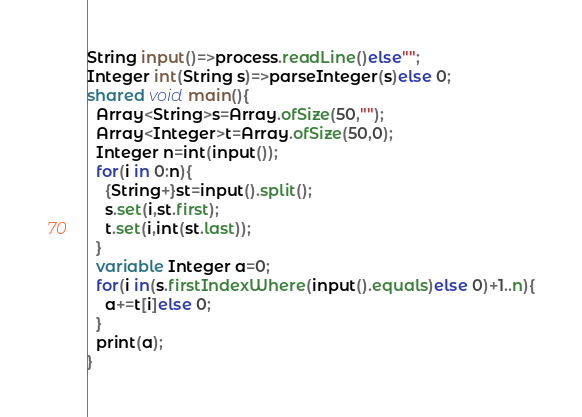<code> <loc_0><loc_0><loc_500><loc_500><_Ceylon_>String input()=>process.readLine()else""; 
Integer int(String s)=>parseInteger(s)else 0;
shared void main(){
  Array<String>s=Array.ofSize(50,"");
  Array<Integer>t=Array.ofSize(50,0);
  Integer n=int(input());
  for(i in 0:n){
    {String+}st=input().split();
    s.set(i,st.first);
    t.set(i,int(st.last));
  }
  variable Integer a=0;
  for(i in(s.firstIndexWhere(input().equals)else 0)+1..n){
    a+=t[i]else 0;
  }
  print(a);
}
</code> 